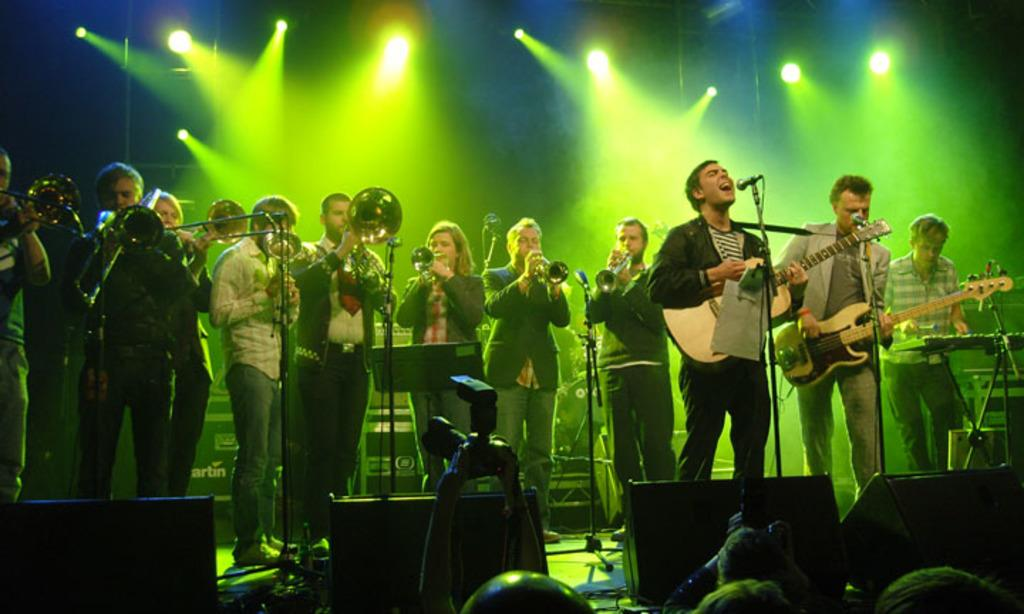What are the people in the image doing? The people in the image are playing musical instruments. What equipment is visible in the image that might be used for amplifying sound? There are microphones in the image. What type of lighting is present in the image? There are lights in the image. What device is used to capture the performance in the image? There is a camera in the image. Who is present in the image to watch the performance? There are audience members in the image. What flavor of jelly is being served to the dogs in the image? There are no dogs or jelly present in the image. 